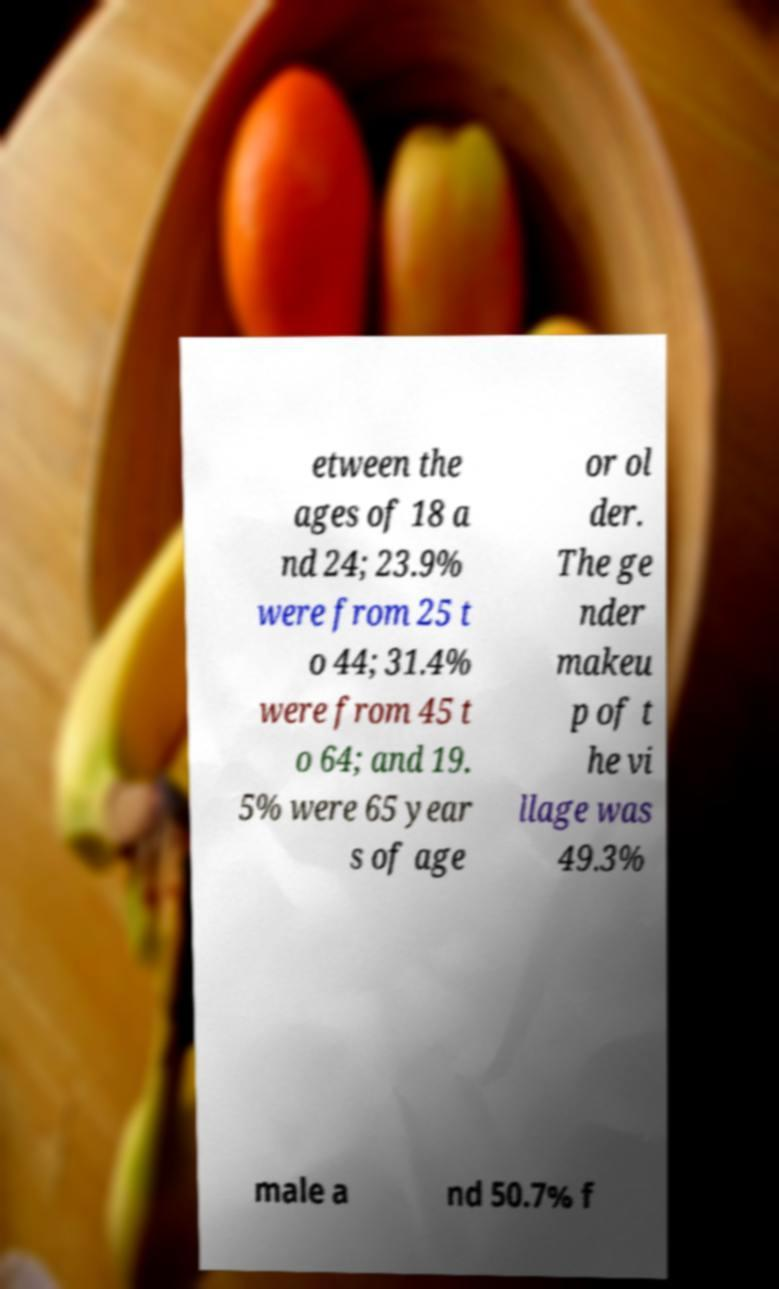Please read and relay the text visible in this image. What does it say? etween the ages of 18 a nd 24; 23.9% were from 25 t o 44; 31.4% were from 45 t o 64; and 19. 5% were 65 year s of age or ol der. The ge nder makeu p of t he vi llage was 49.3% male a nd 50.7% f 